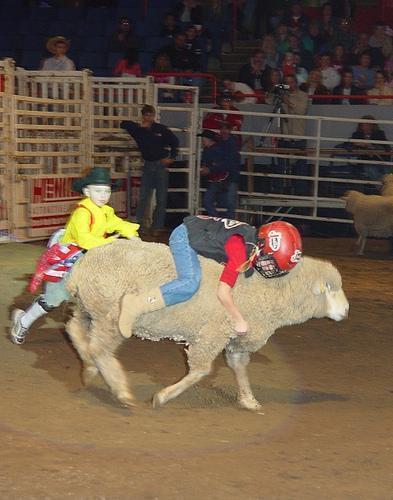Why are the little people riding the sheep?
Select the accurate answer and provide explanation: 'Answer: answer
Rationale: rationale.'
Options: Are children, no horses, forced to, going home. Answer: are children.
Rationale: Sheep are smaller animals and only a child could ride one comfortably. 